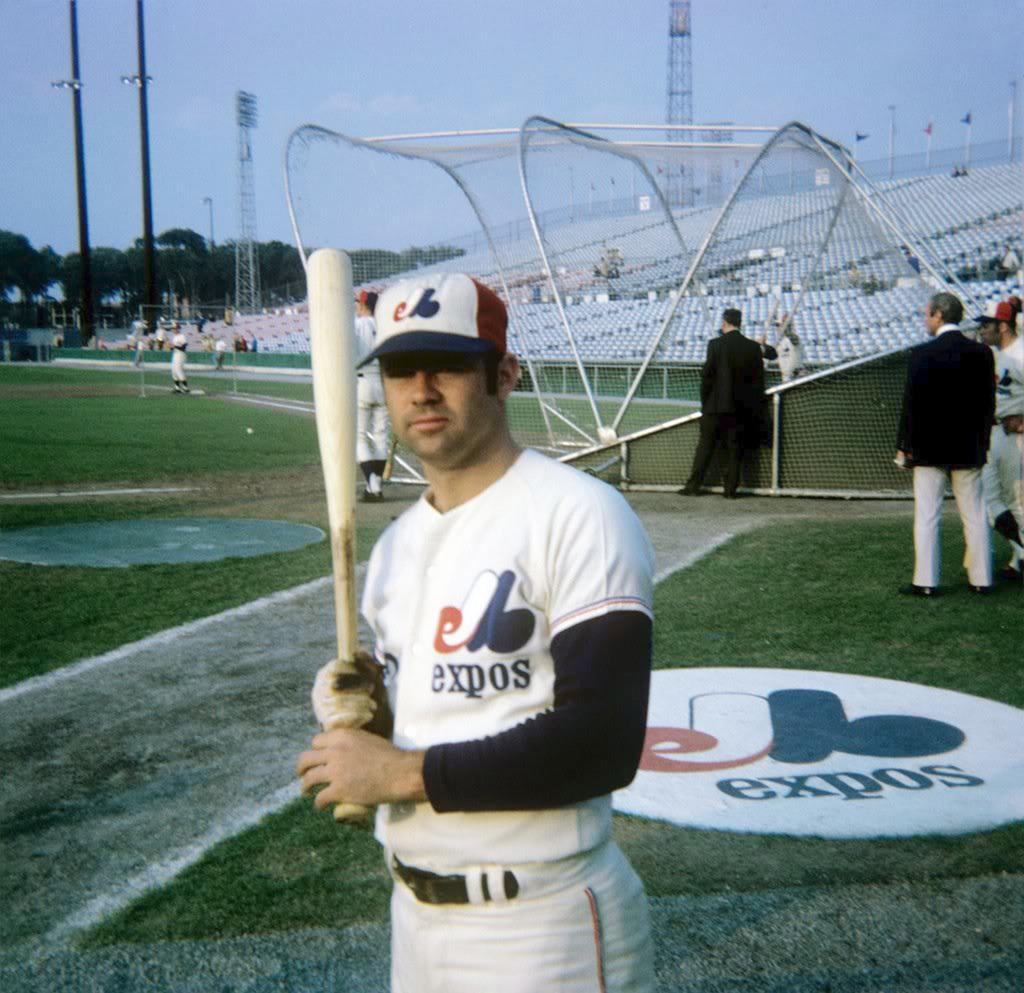<image>
Describe the image concisely. a man with an Expos jersey on at the field 